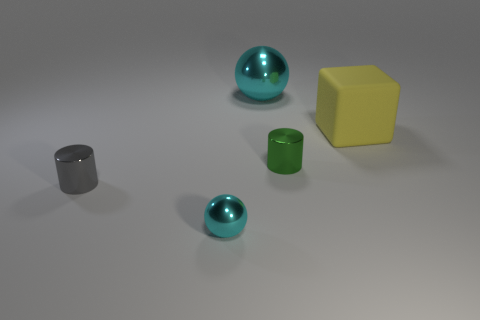What size is the other sphere that is the same color as the big ball?
Your answer should be very brief. Small. Is the color of the block the same as the big shiny ball?
Provide a short and direct response. No. Are there any other things that have the same color as the big metallic thing?
Provide a short and direct response. Yes. There is a large shiny sphere; how many tiny cyan things are left of it?
Ensure brevity in your answer.  1. There is a small cyan shiny thing; is it the same shape as the cyan metallic object that is behind the big yellow thing?
Offer a very short reply. Yes. Are there any other objects that have the same shape as the gray metal object?
Offer a very short reply. Yes. The cyan metal object behind the tiny cylinder that is behind the gray cylinder is what shape?
Ensure brevity in your answer.  Sphere. What is the shape of the cyan metal thing in front of the green thing?
Offer a very short reply. Sphere. There is a metallic cylinder right of the big sphere; is its color the same as the metallic ball in front of the big yellow rubber cube?
Keep it short and to the point. No. How many things are in front of the big cyan object and left of the yellow matte block?
Your response must be concise. 3. 